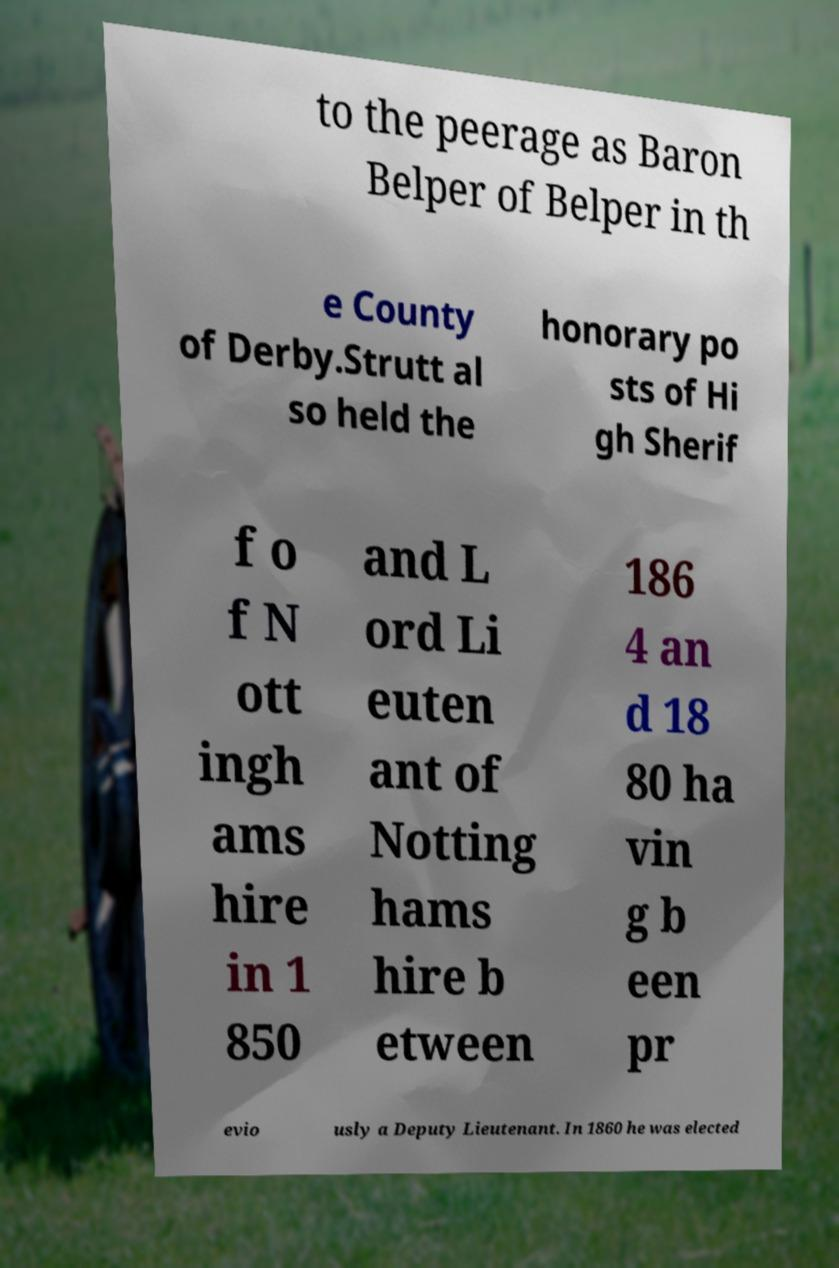What messages or text are displayed in this image? I need them in a readable, typed format. to the peerage as Baron Belper of Belper in th e County of Derby.Strutt al so held the honorary po sts of Hi gh Sherif f o f N ott ingh ams hire in 1 850 and L ord Li euten ant of Notting hams hire b etween 186 4 an d 18 80 ha vin g b een pr evio usly a Deputy Lieutenant. In 1860 he was elected 